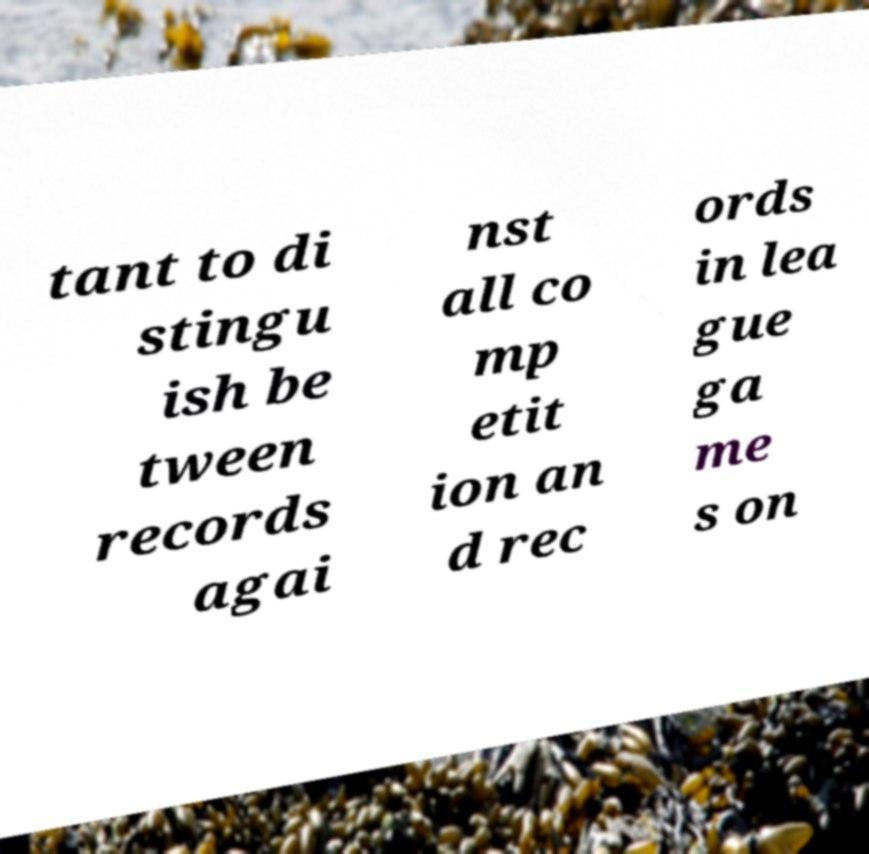Please identify and transcribe the text found in this image. tant to di stingu ish be tween records agai nst all co mp etit ion an d rec ords in lea gue ga me s on 